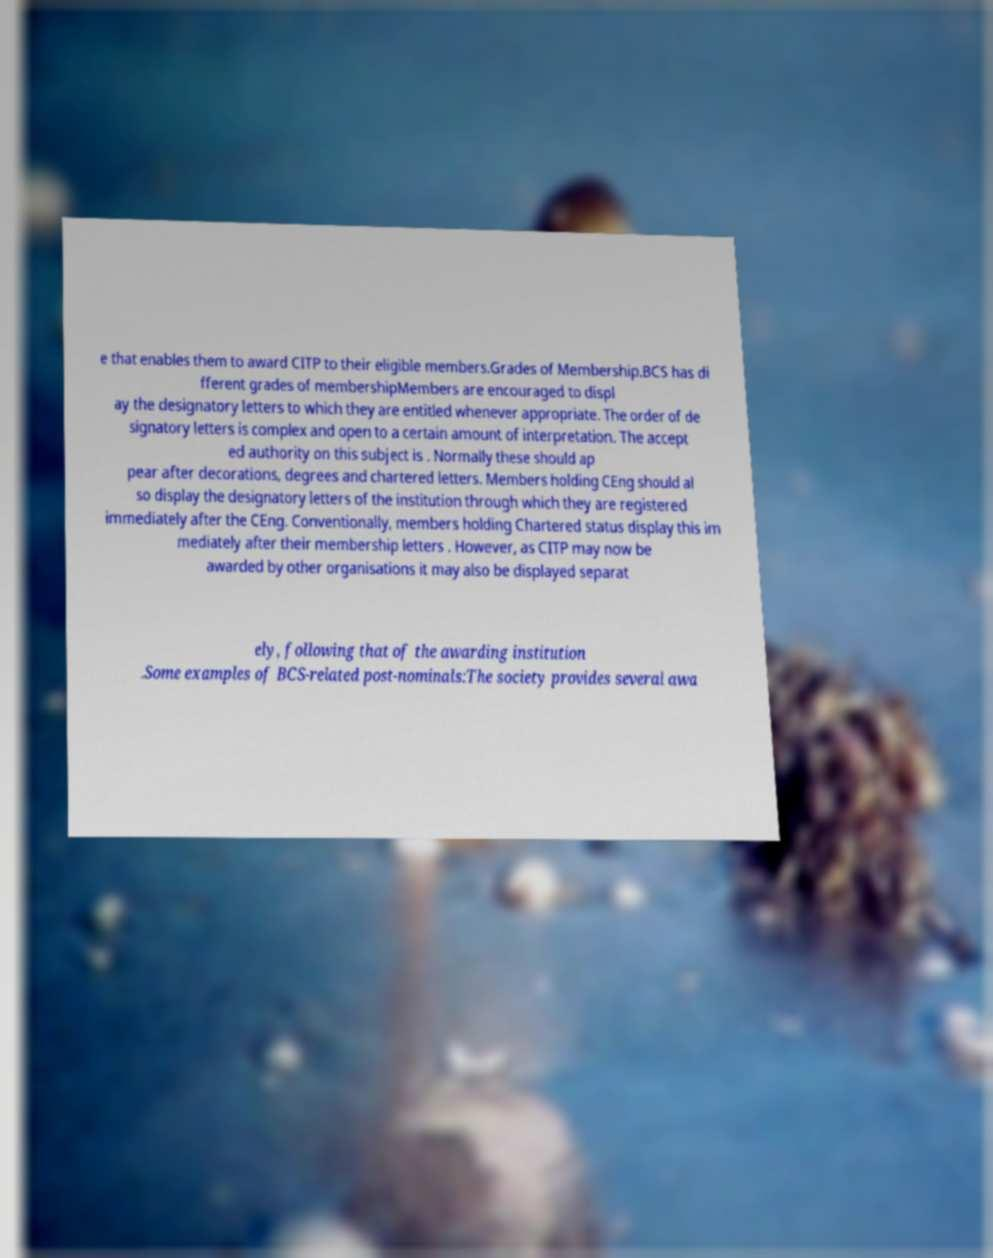Can you accurately transcribe the text from the provided image for me? e that enables them to award CITP to their eligible members.Grades of Membership.BCS has di fferent grades of membershipMembers are encouraged to displ ay the designatory letters to which they are entitled whenever appropriate. The order of de signatory letters is complex and open to a certain amount of interpretation. The accept ed authority on this subject is . Normally these should ap pear after decorations, degrees and chartered letters. Members holding CEng should al so display the designatory letters of the institution through which they are registered immediately after the CEng. Conventionally, members holding Chartered status display this im mediately after their membership letters . However, as CITP may now be awarded by other organisations it may also be displayed separat ely, following that of the awarding institution .Some examples of BCS-related post-nominals:The society provides several awa 